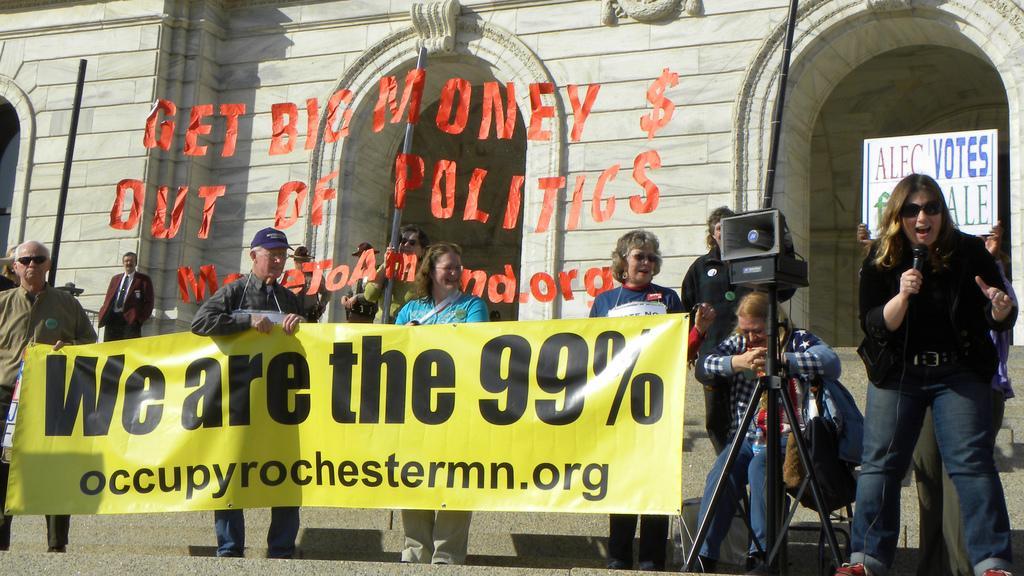Could you give a brief overview of what you see in this image? In the center of the image there are people holding a banner. In the background of the image there is a building. To the right side of the image there is a lady holding a mic. 